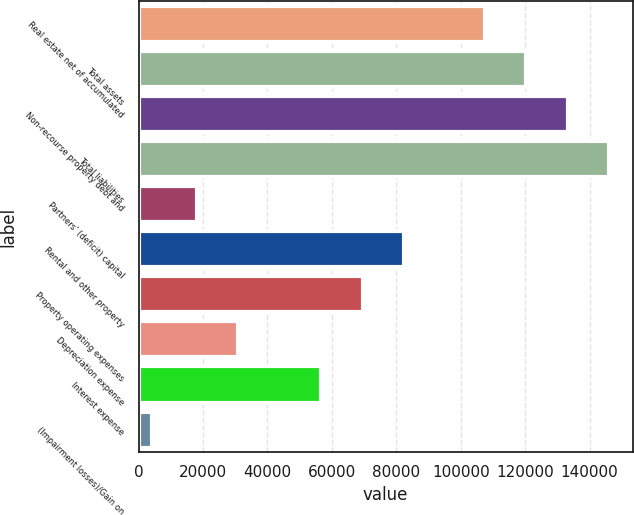<chart> <loc_0><loc_0><loc_500><loc_500><bar_chart><fcel>Real estate net of accumulated<fcel>Total assets<fcel>Non-recourse property debt and<fcel>Total liabilities<fcel>Partners' (deficit) capital<fcel>Rental and other property<fcel>Property operating expenses<fcel>Depreciation expense<fcel>Interest expense<fcel>(Impairment losses)/Gain on<nl><fcel>107419<fcel>120282<fcel>133144<fcel>146007<fcel>18109<fcel>82422.5<fcel>69559.8<fcel>30971.7<fcel>56697.1<fcel>4140<nl></chart> 